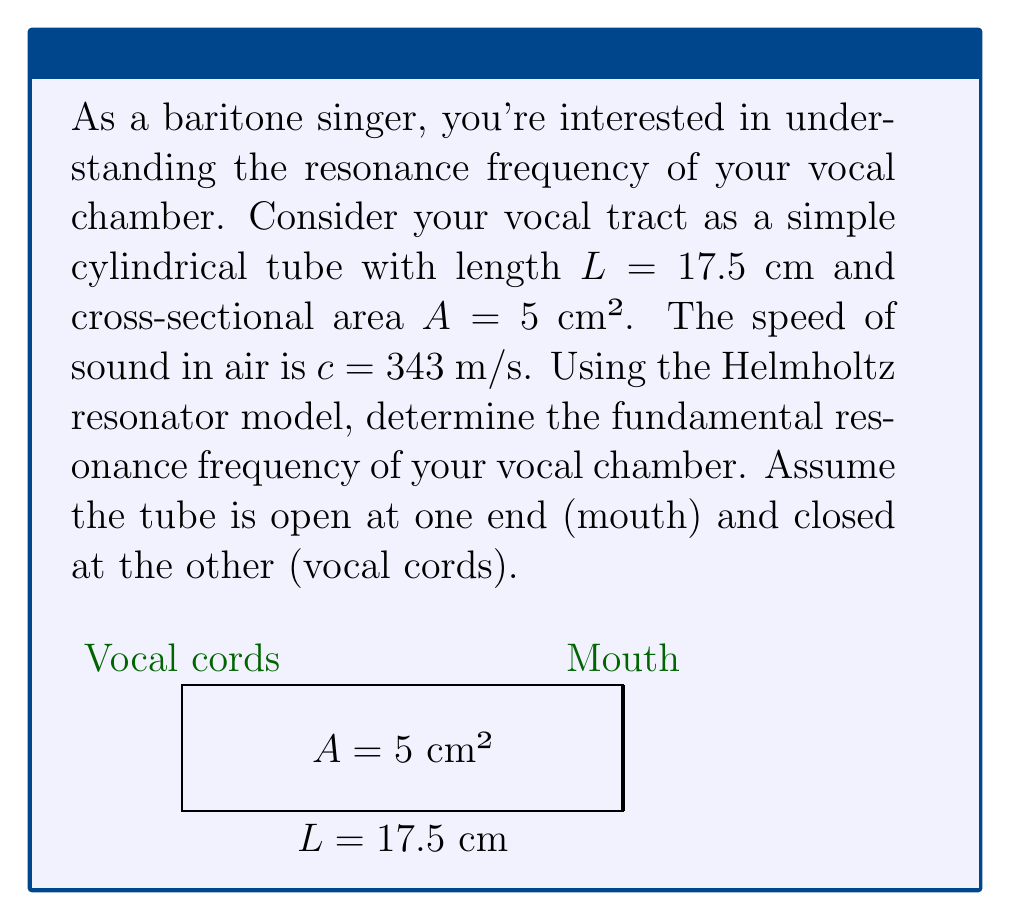Provide a solution to this math problem. Let's approach this step-by-step:

1) The Helmholtz resonator model for a tube open at one end and closed at the other gives the fundamental frequency as:

   $$f = \frac{c}{4L}$$

   Where $f$ is the frequency, $c$ is the speed of sound, and $L$ is the length of the tube.

2) We're given:
   $L = 17.5$ cm = $0.175$ m
   $c = 343$ m/s

3) Substituting these values into the equation:

   $$f = \frac{343}{4 \times 0.175}$$

4) Simplifying:
   
   $$f = \frac{343}{0.7} = 490$$

5) Rounding to the nearest whole number:

   $$f \approx 490 \text{ Hz}$$

Note: The cross-sectional area $A$ doesn't affect the fundamental frequency in this simple model, but it would influence the intensity and quality of the sound produced.
Answer: 490 Hz 